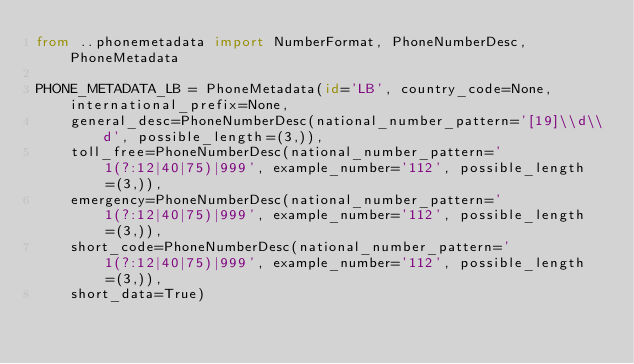<code> <loc_0><loc_0><loc_500><loc_500><_Python_>from ..phonemetadata import NumberFormat, PhoneNumberDesc, PhoneMetadata

PHONE_METADATA_LB = PhoneMetadata(id='LB', country_code=None, international_prefix=None,
    general_desc=PhoneNumberDesc(national_number_pattern='[19]\\d\\d', possible_length=(3,)),
    toll_free=PhoneNumberDesc(national_number_pattern='1(?:12|40|75)|999', example_number='112', possible_length=(3,)),
    emergency=PhoneNumberDesc(national_number_pattern='1(?:12|40|75)|999', example_number='112', possible_length=(3,)),
    short_code=PhoneNumberDesc(national_number_pattern='1(?:12|40|75)|999', example_number='112', possible_length=(3,)),
    short_data=True)
</code> 